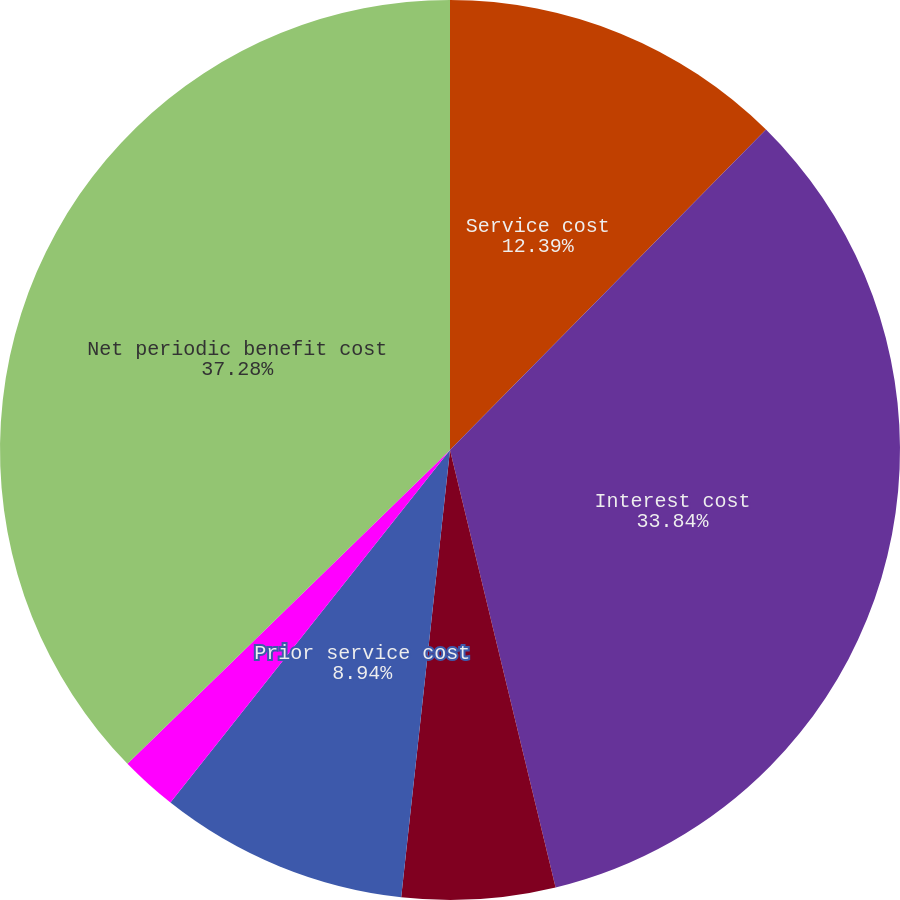<chart> <loc_0><loc_0><loc_500><loc_500><pie_chart><fcel>Service cost<fcel>Interest cost<fcel>Expected return on assets<fcel>Prior service cost<fcel>Unrecognized net loss (gain)<fcel>Net periodic benefit cost<nl><fcel>12.39%<fcel>33.84%<fcel>5.5%<fcel>8.94%<fcel>2.05%<fcel>37.28%<nl></chart> 